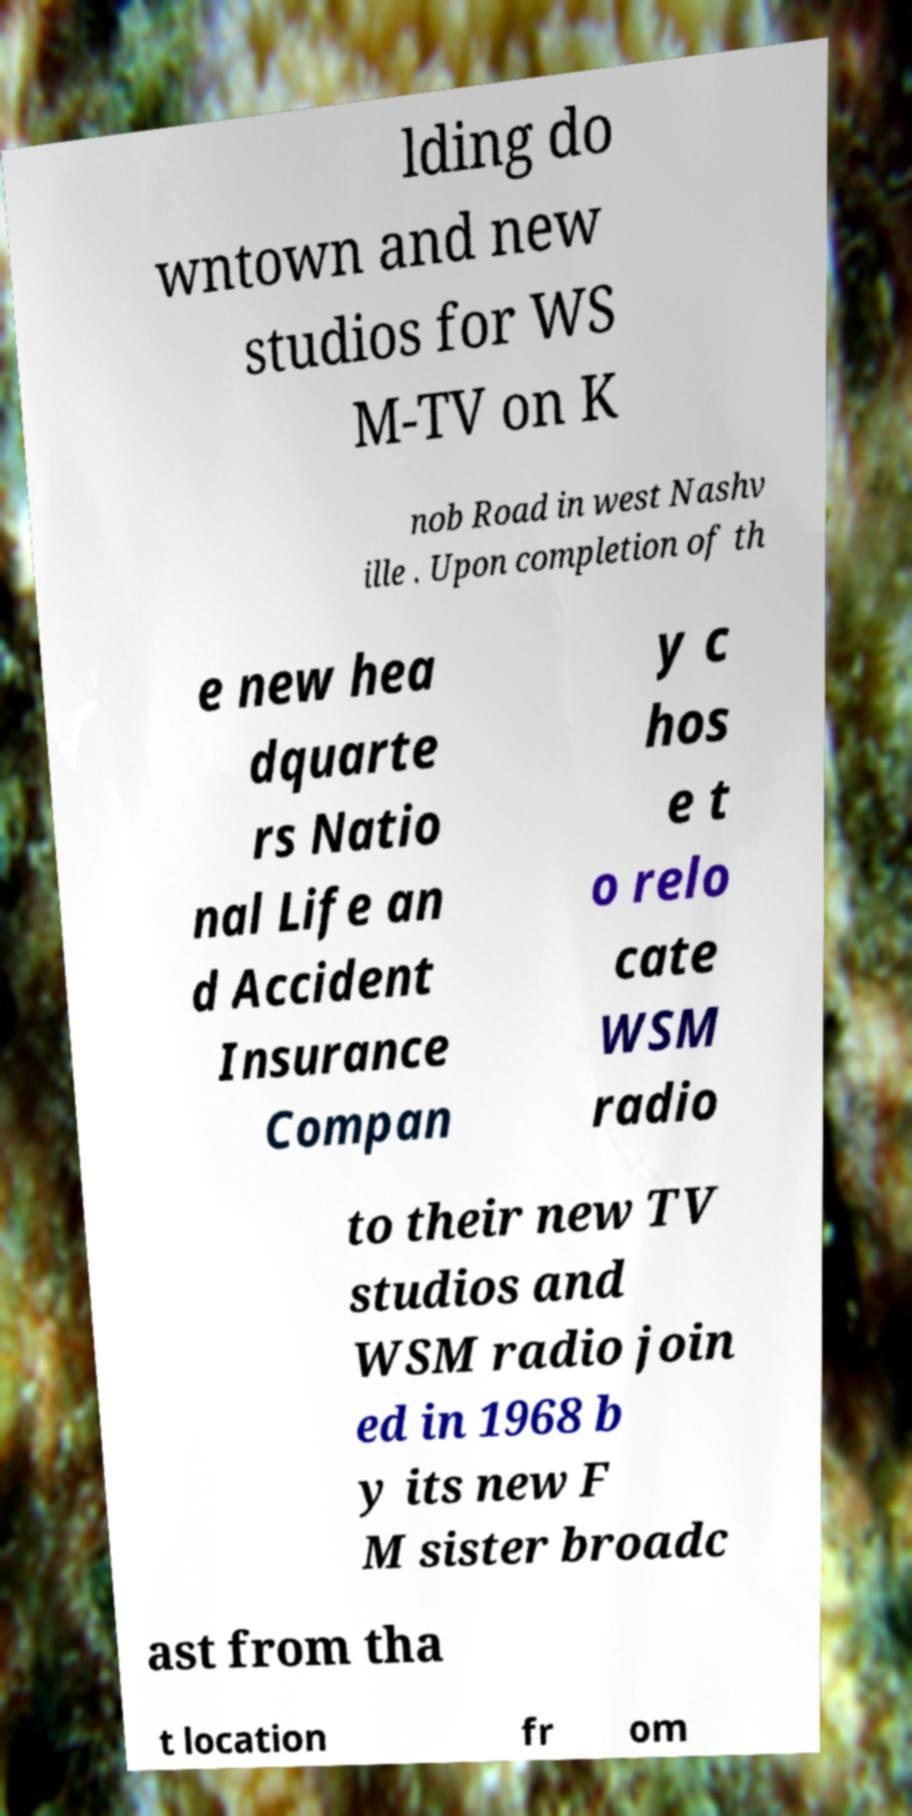I need the written content from this picture converted into text. Can you do that? lding do wntown and new studios for WS M-TV on K nob Road in west Nashv ille . Upon completion of th e new hea dquarte rs Natio nal Life an d Accident Insurance Compan y c hos e t o relo cate WSM radio to their new TV studios and WSM radio join ed in 1968 b y its new F M sister broadc ast from tha t location fr om 